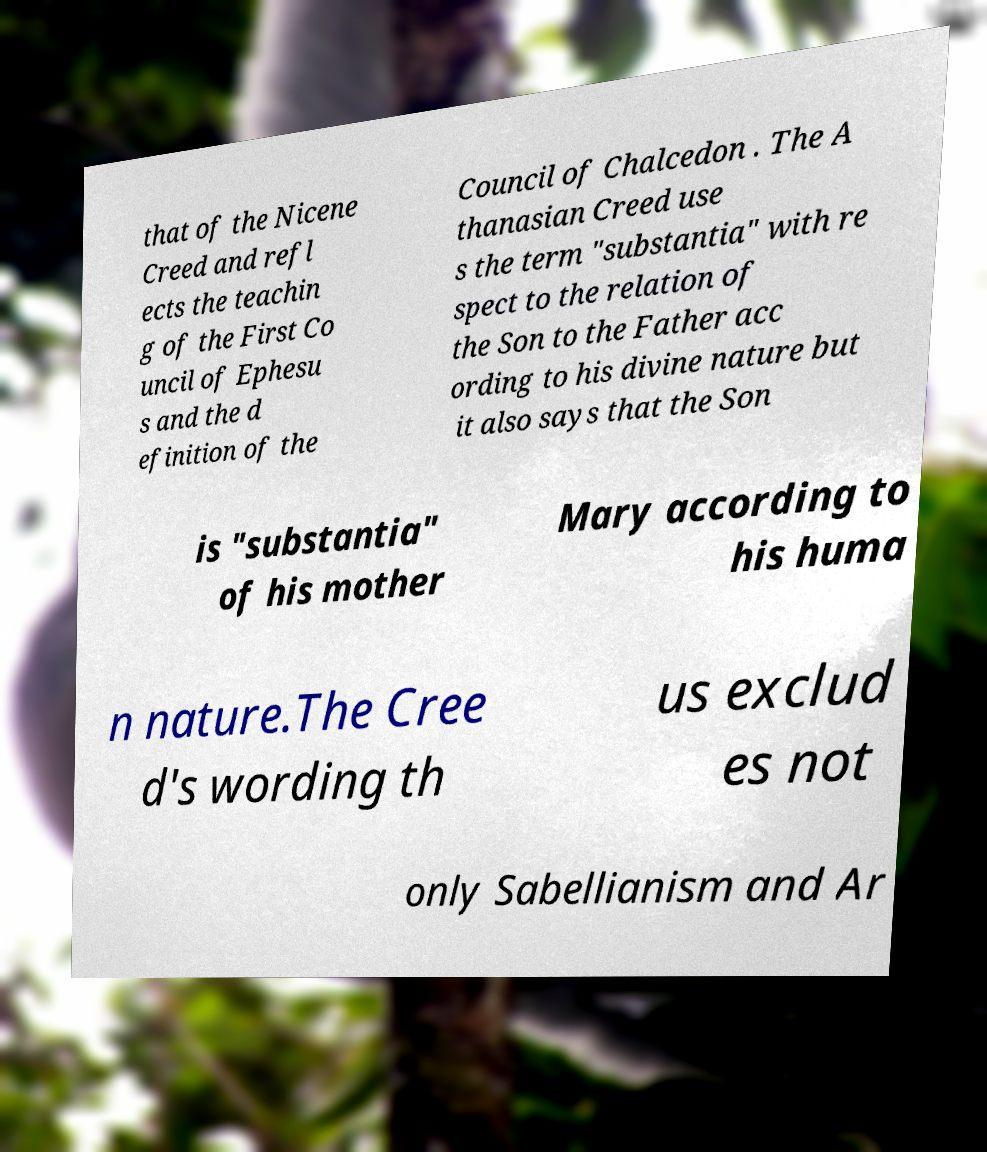Please read and relay the text visible in this image. What does it say? that of the Nicene Creed and refl ects the teachin g of the First Co uncil of Ephesu s and the d efinition of the Council of Chalcedon . The A thanasian Creed use s the term "substantia" with re spect to the relation of the Son to the Father acc ording to his divine nature but it also says that the Son is "substantia" of his mother Mary according to his huma n nature.The Cree d's wording th us exclud es not only Sabellianism and Ar 